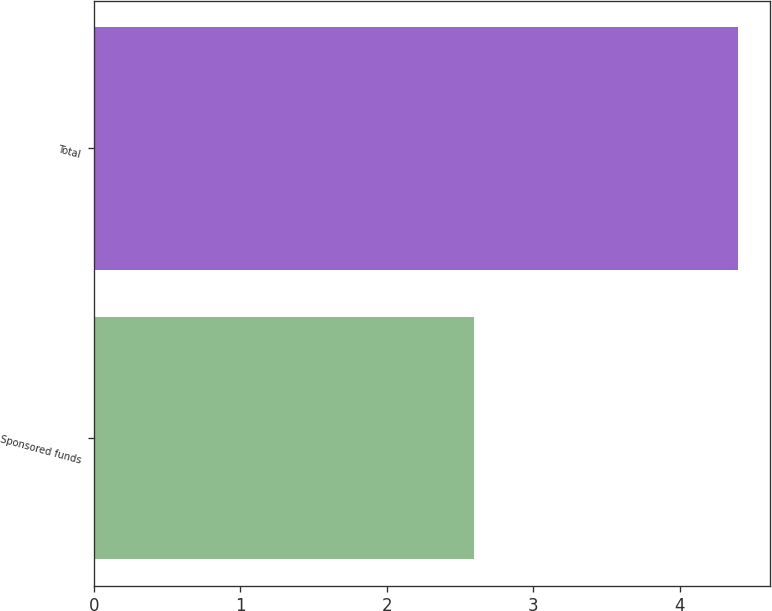Convert chart to OTSL. <chart><loc_0><loc_0><loc_500><loc_500><bar_chart><fcel>Sponsored funds<fcel>Total<nl><fcel>2.6<fcel>4.4<nl></chart> 